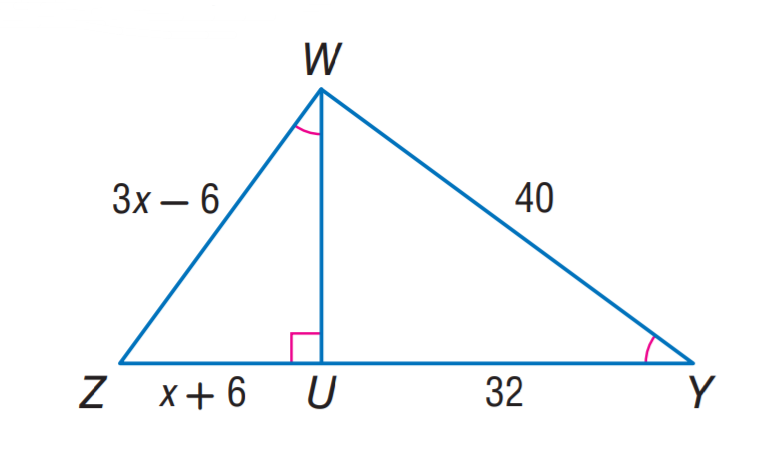Question: Find W Z.
Choices:
A. 18
B. 24
C. 30
D. 32
Answer with the letter. Answer: C Question: Find U Z.
Choices:
A. 12
B. 18
C. 24
D. 32
Answer with the letter. Answer: B 